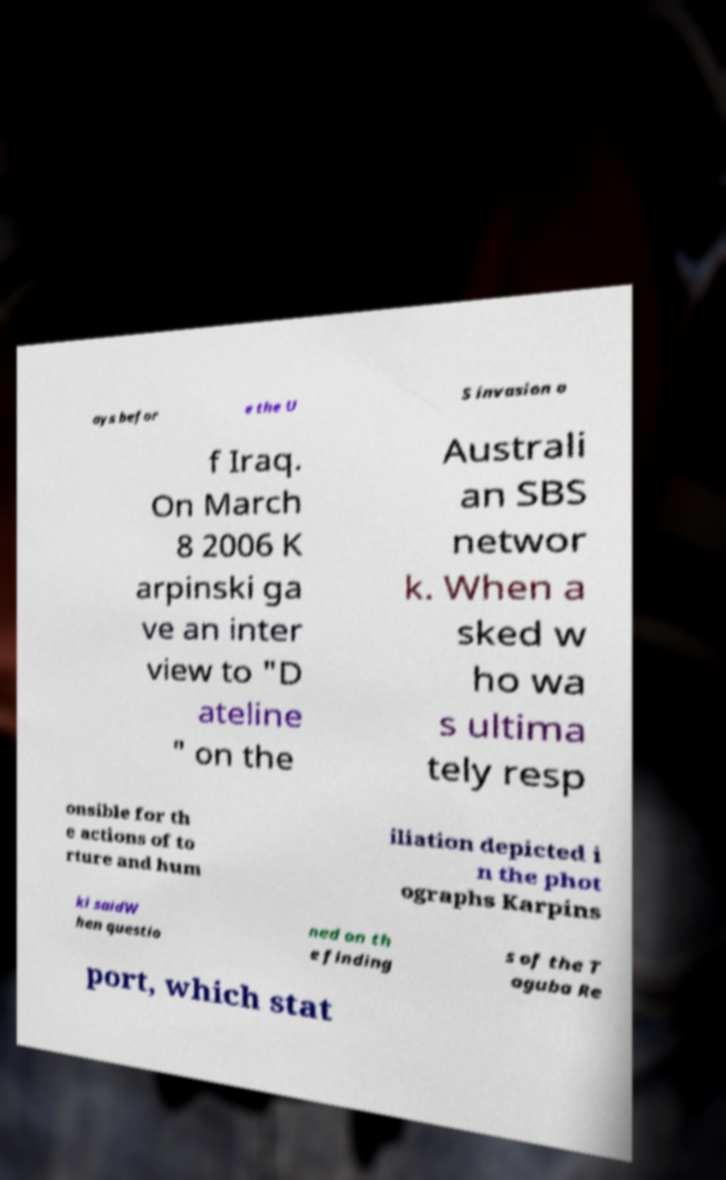Can you accurately transcribe the text from the provided image for me? ays befor e the U S invasion o f Iraq. On March 8 2006 K arpinski ga ve an inter view to "D ateline " on the Australi an SBS networ k. When a sked w ho wa s ultima tely resp onsible for th e actions of to rture and hum iliation depicted i n the phot ographs Karpins ki saidW hen questio ned on th e finding s of the T aguba Re port, which stat 